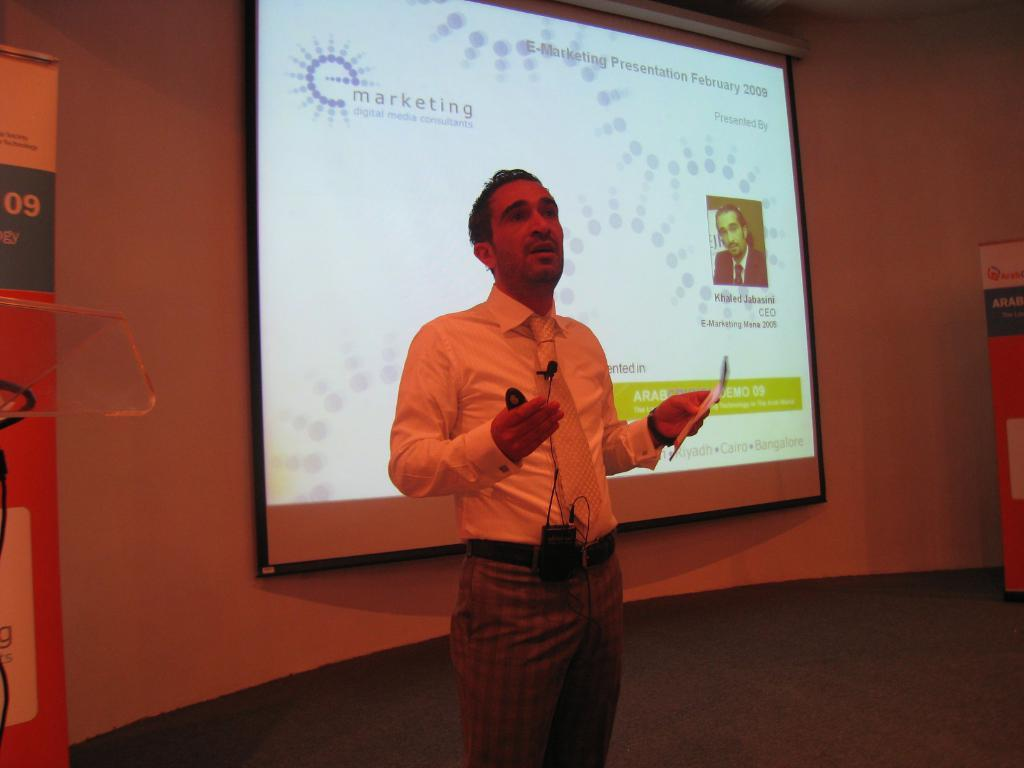What is the main subject of the image? There is a person standing on a dais in the image. What can be seen in the background of the image? There is an advertisement and a screen in the background of the image. What type of frame is around the person on the dais? There is no frame visible around the person on the dais in the image. How many attempts can be seen being made by the person on the dais? The image does not show any attempts being made by the person on the dais. What sound can be heard coming from the bells in the image? There are no bells present in the image. 